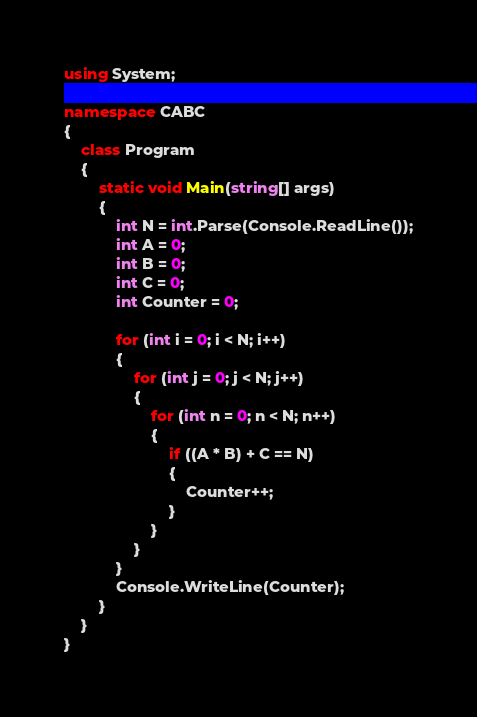Convert code to text. <code><loc_0><loc_0><loc_500><loc_500><_C#_>using System;

namespace CABC
{
    class Program
    {
        static void Main(string[] args)
        {
            int N = int.Parse(Console.ReadLine());
            int A = 0;
            int B = 0;
            int C = 0;
            int Counter = 0;

            for (int i = 0; i < N; i++)
            {
                for (int j = 0; j < N; j++)
                {
                    for (int n = 0; n < N; n++)
                    {
                        if ((A * B) + C == N)
                        {
                            Counter++;
                        }
                    }
                }
            }
            Console.WriteLine(Counter);
        }
    }
}
</code> 